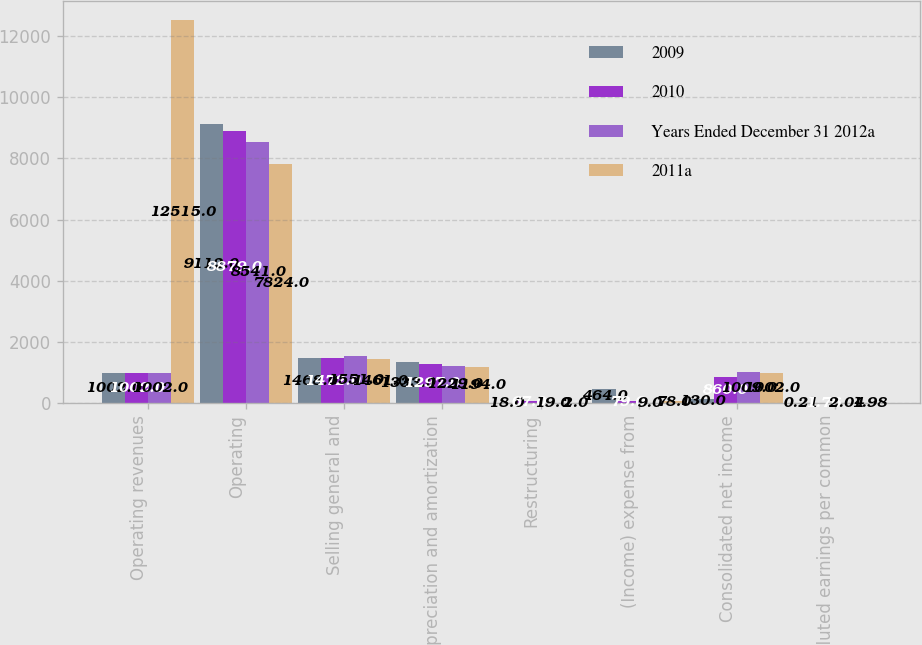<chart> <loc_0><loc_0><loc_500><loc_500><stacked_bar_chart><ecel><fcel>Operating revenues<fcel>Operating<fcel>Selling general and<fcel>Depreciation and amortization<fcel>Restructuring<fcel>(Income) expense from<fcel>Consolidated net income<fcel>Diluted earnings per common<nl><fcel>2009<fcel>1002<fcel>9112<fcel>1468<fcel>1333<fcel>18<fcel>464<fcel>130<fcel>0.21<nl><fcel>2010<fcel>1002<fcel>8879<fcel>1472<fcel>1297<fcel>67<fcel>79<fcel>860<fcel>1.76<nl><fcel>Years Ended December 31 2012a<fcel>1002<fcel>8541<fcel>1551<fcel>1229<fcel>19<fcel>9<fcel>1009<fcel>2.04<nl><fcel>2011a<fcel>12515<fcel>7824<fcel>1461<fcel>1194<fcel>2<fcel>78<fcel>1002<fcel>1.98<nl></chart> 